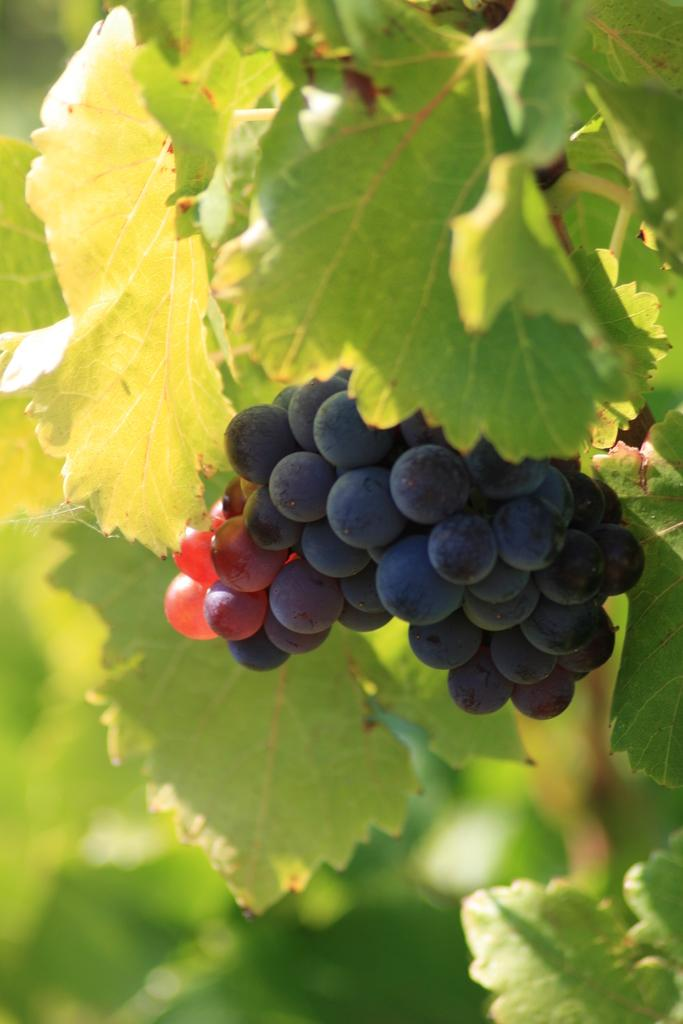What type of fruit is visible in the image? There is a bunch of black grapes in the image. What else can be seen in the image besides the grapes? There are green leaves in the image. What advice does the father give about the sea in the image? There is no father or sea present in the image, so it is not possible to answer that question. 